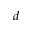<formula> <loc_0><loc_0><loc_500><loc_500>d</formula> 